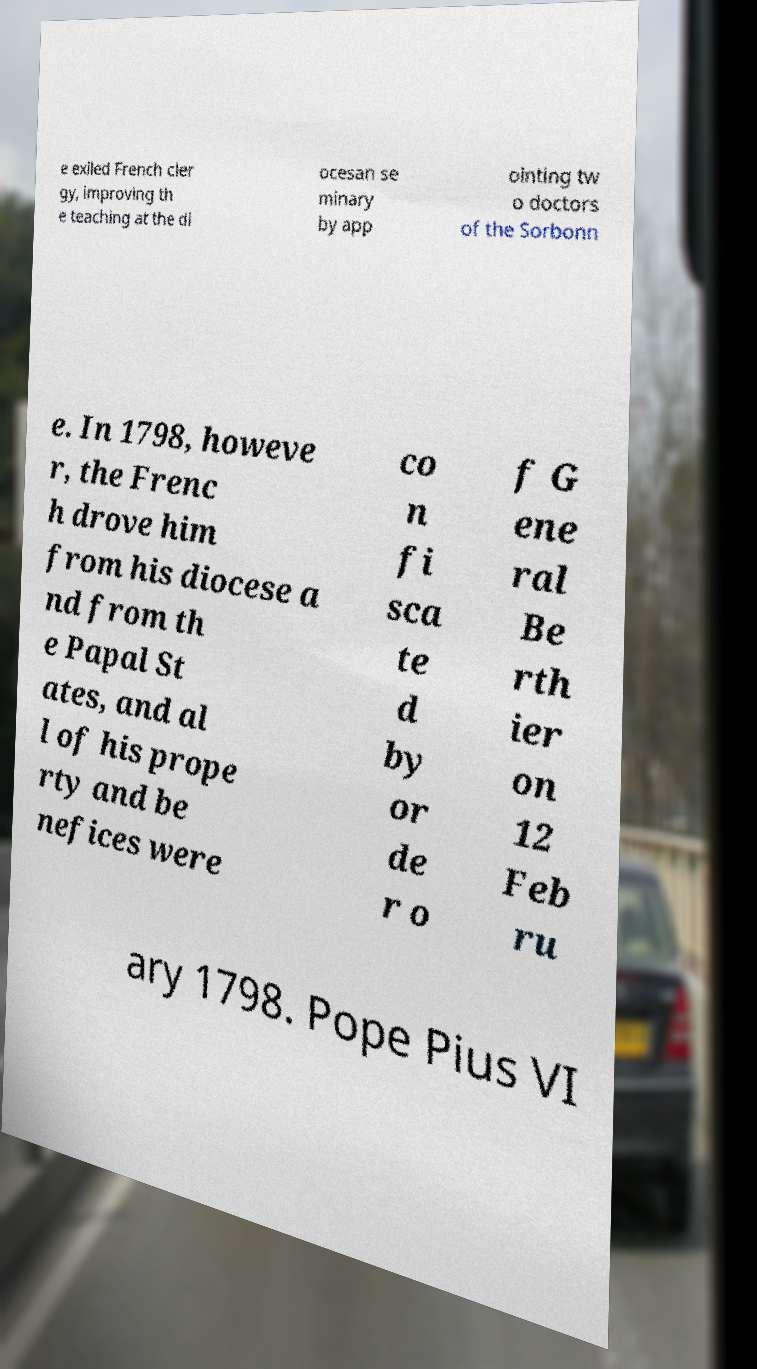Could you extract and type out the text from this image? e exiled French cler gy, improving th e teaching at the di ocesan se minary by app ointing tw o doctors of the Sorbonn e. In 1798, howeve r, the Frenc h drove him from his diocese a nd from th e Papal St ates, and al l of his prope rty and be nefices were co n fi sca te d by or de r o f G ene ral Be rth ier on 12 Feb ru ary 1798. Pope Pius VI 